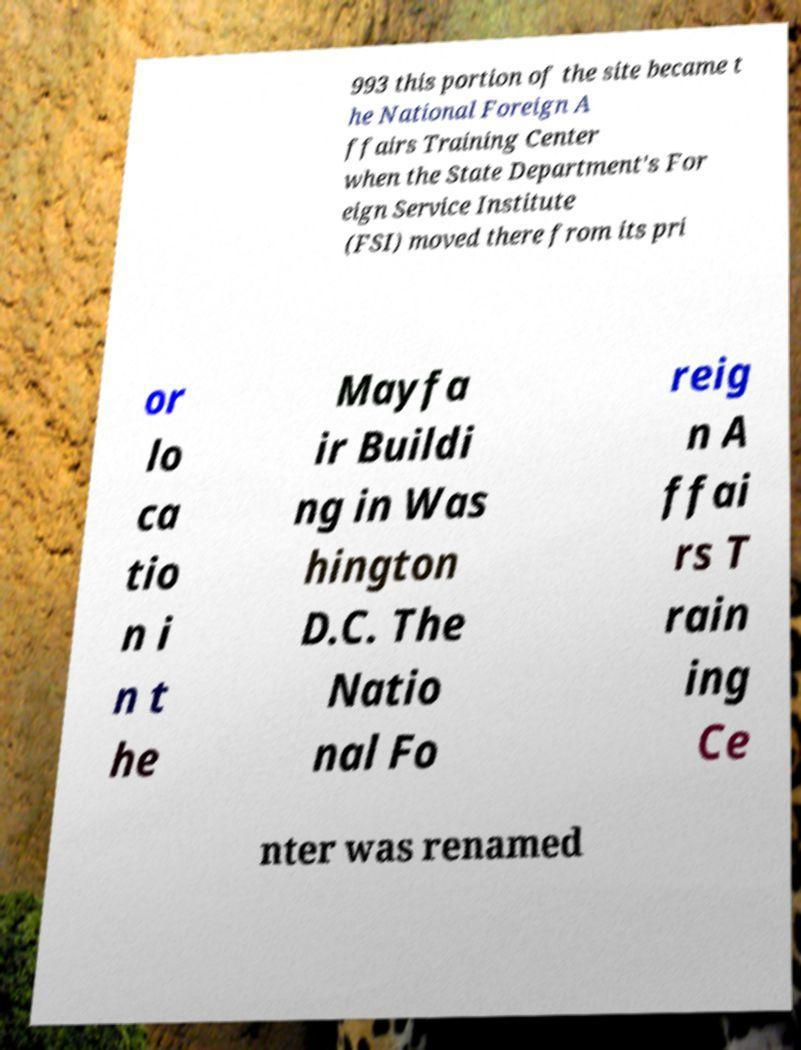Could you extract and type out the text from this image? 993 this portion of the site became t he National Foreign A ffairs Training Center when the State Department's For eign Service Institute (FSI) moved there from its pri or lo ca tio n i n t he Mayfa ir Buildi ng in Was hington D.C. The Natio nal Fo reig n A ffai rs T rain ing Ce nter was renamed 